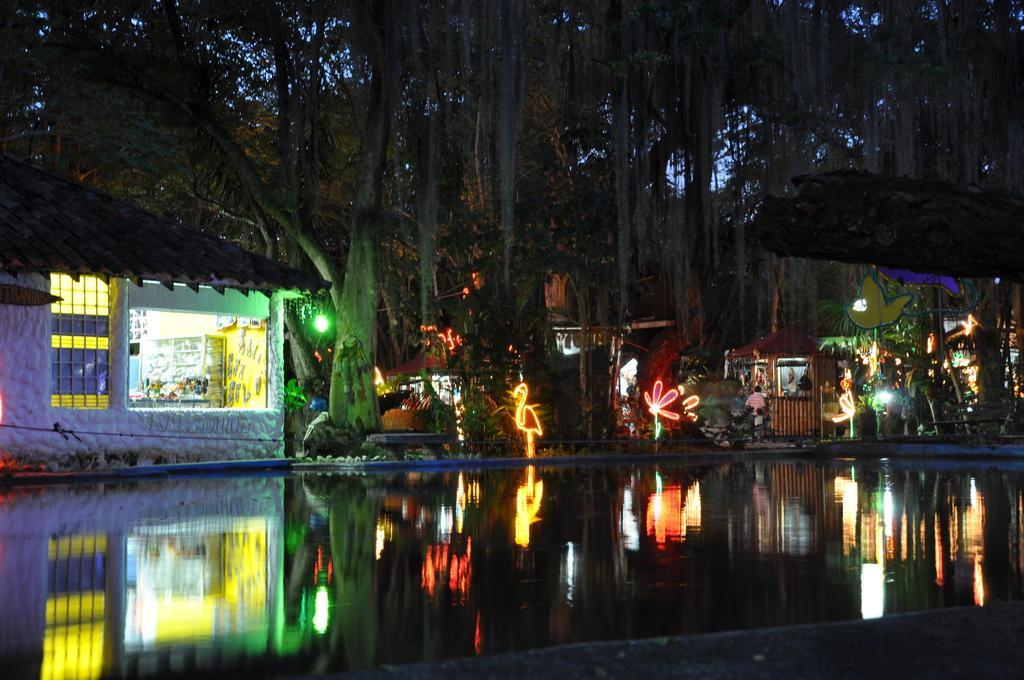Could you give a brief overview of what you see in this image? In this image we can see some water and in the background of the image there are some huts, trees, there are some lights in different shapes and top of the image there is clear sky. 